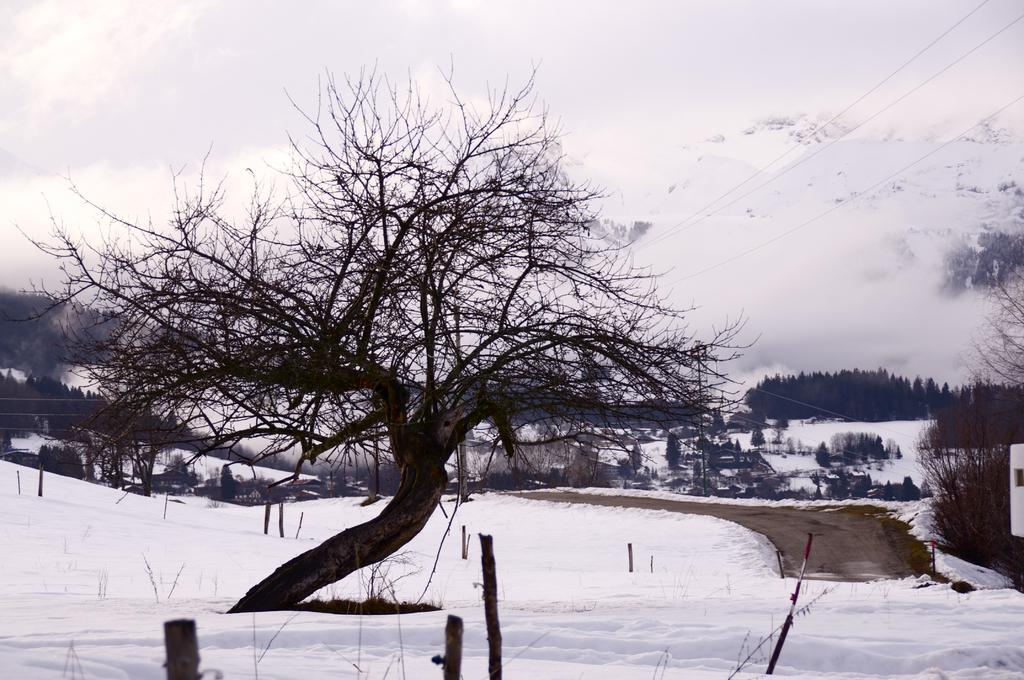What type of tree can be seen in the image? There is a dried tree in the image. What else can be seen in the image besides the dried tree? There are other stems, plants, trees, electrical wires, and a road in the image. What is covering the ground in the image? The ground is covered with snow in the image. What is visible at the top of the image? The sky is visible at the top of the image. What type of bread can be seen in the image? There is no bread present in the image. Can you tell me how many cakes are visible in the image? There are no cakes present in the image. 